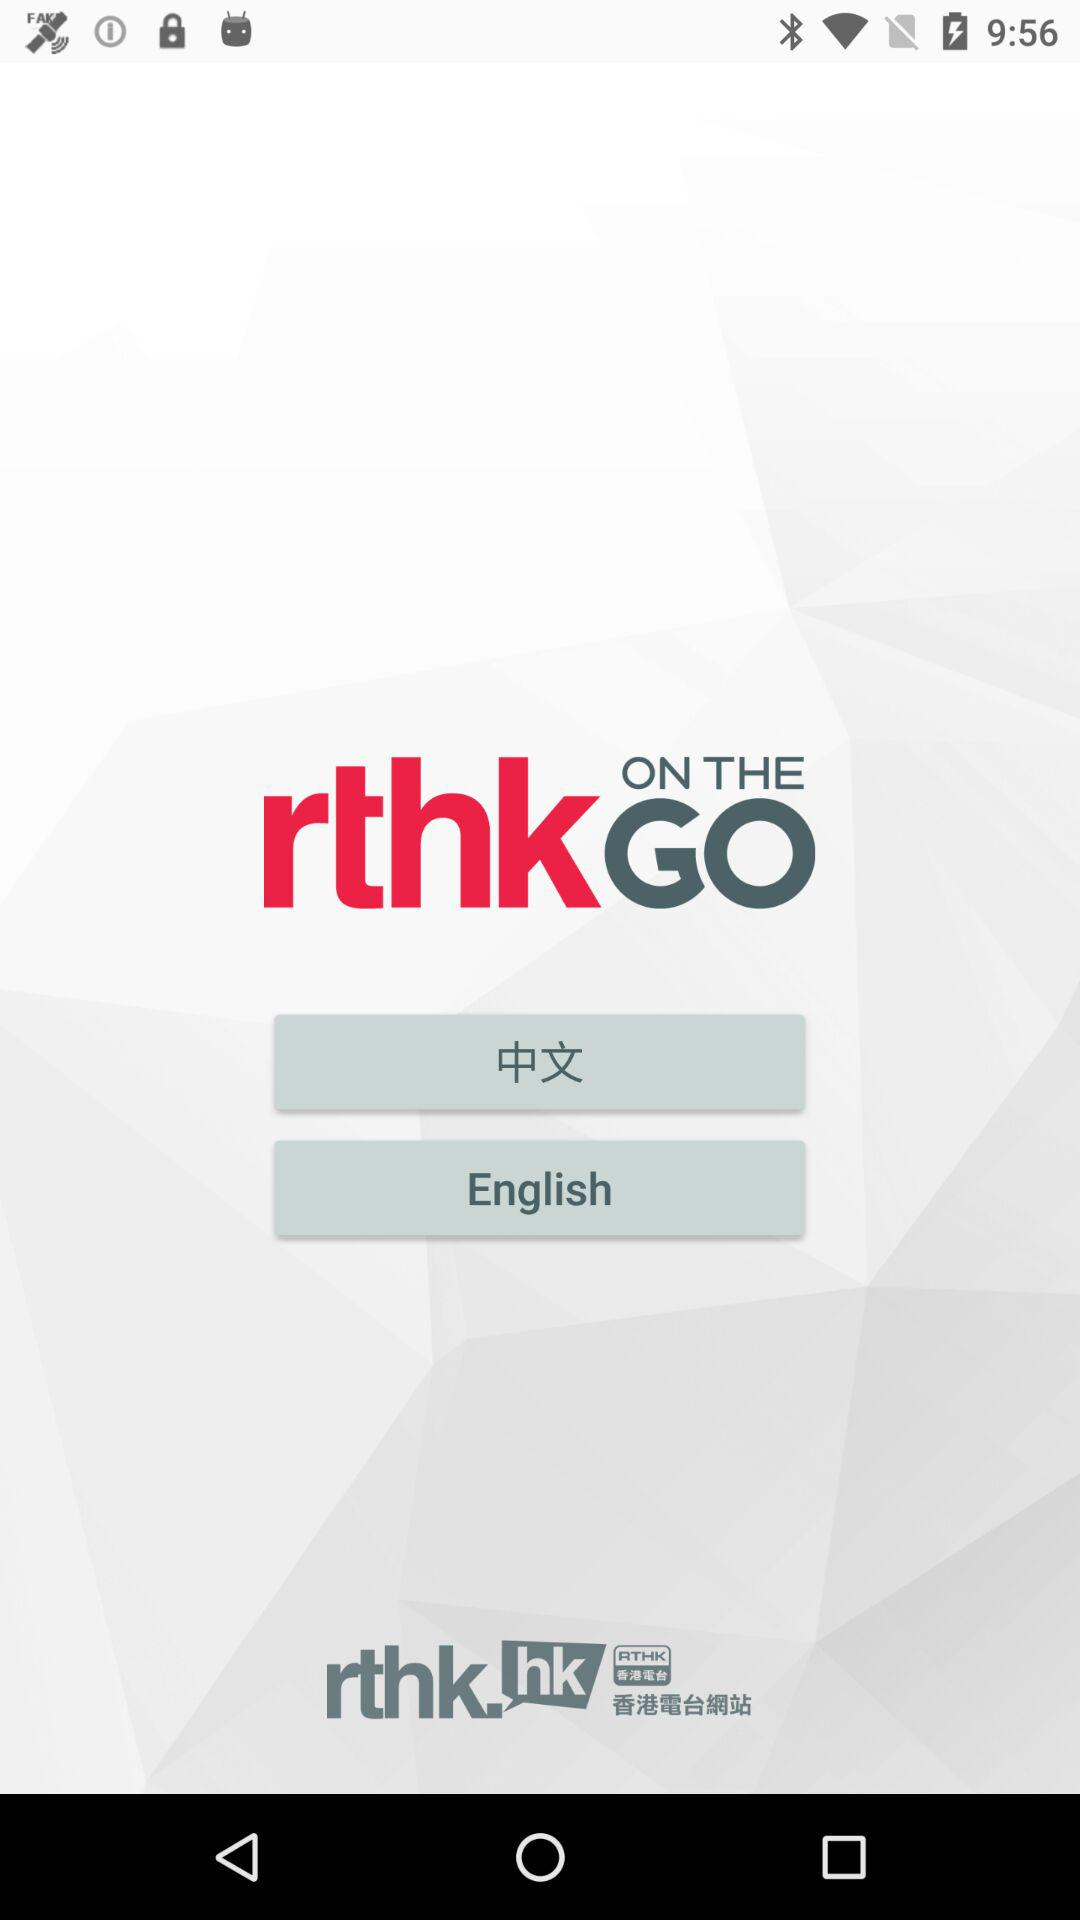What is the application name? The application name is " rthk ON THE GO". 